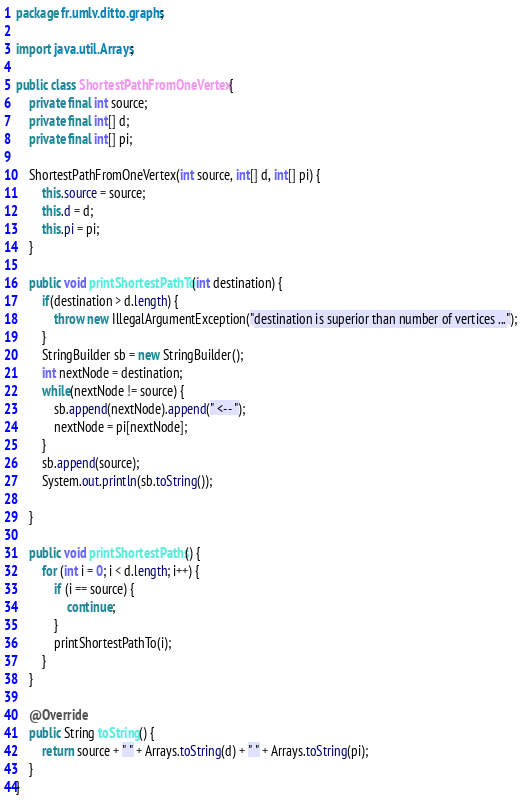Convert code to text. <code><loc_0><loc_0><loc_500><loc_500><_Java_>package fr.umlv.ditto.graphs;

import java.util.Arrays;

public class ShortestPathFromOneVertex {
	private final int source;
	private final int[] d;
	private final int[] pi;

	ShortestPathFromOneVertex(int source, int[] d, int[] pi) {
		this.source = source;
		this.d = d;
		this.pi = pi;
	}

	public void printShortestPathTo(int destination) {
		if(destination > d.length) {
			throw new IllegalArgumentException("destination is superior than number of vertices ...");
		}
		StringBuilder sb = new StringBuilder();
		int nextNode = destination;
		while(nextNode != source) {
			sb.append(nextNode).append(" <-- ");
			nextNode = pi[nextNode];
		}
		sb.append(source);
		System.out.println(sb.toString());
		
	}

	public void printShortestPaths() {
		for (int i = 0; i < d.length; i++) {
			if (i == source) {
				continue;
			}
			printShortestPathTo(i);
		}
	}

	@Override
	public String toString() {
		return source + " " + Arrays.toString(d) + " " + Arrays.toString(pi);
	}
}
</code> 